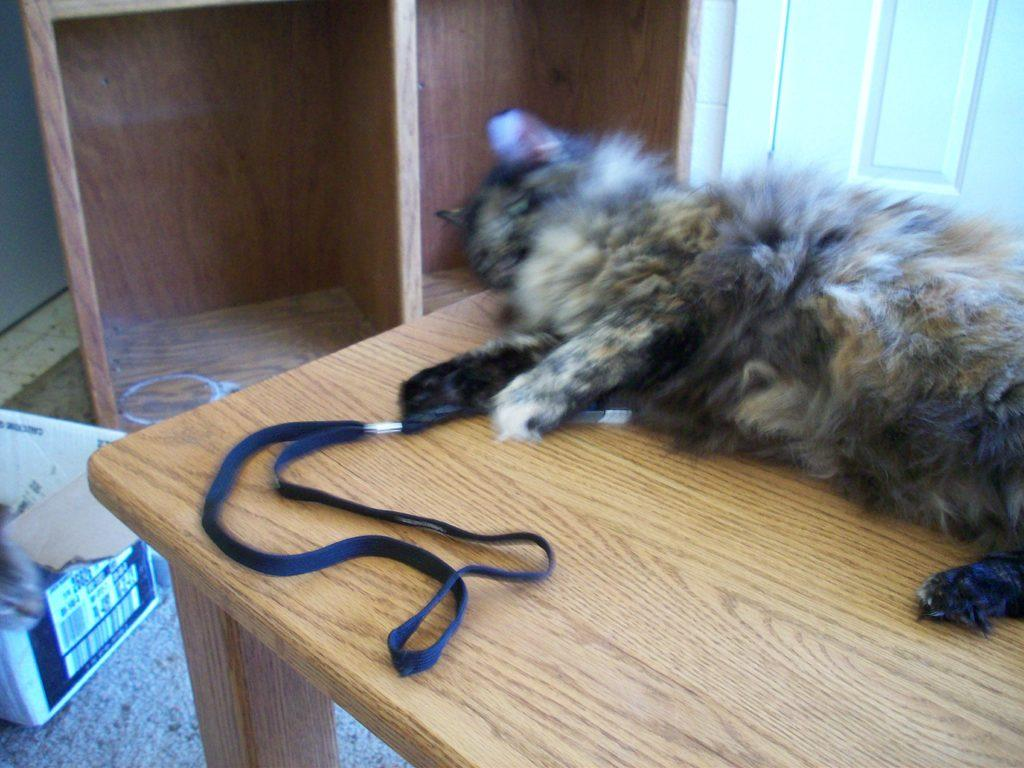What animal can be seen lying on the table in the image? There is a cat lying on the table in the image. What type of furniture is present in the image? There are wooden shelves in the image. What object is placed on the carpet? There is a box placed on the carpet. How many rings can be seen on the cat's tail in the image? There are no rings visible on the cat's tail in the image, as the cat does not have any rings. 